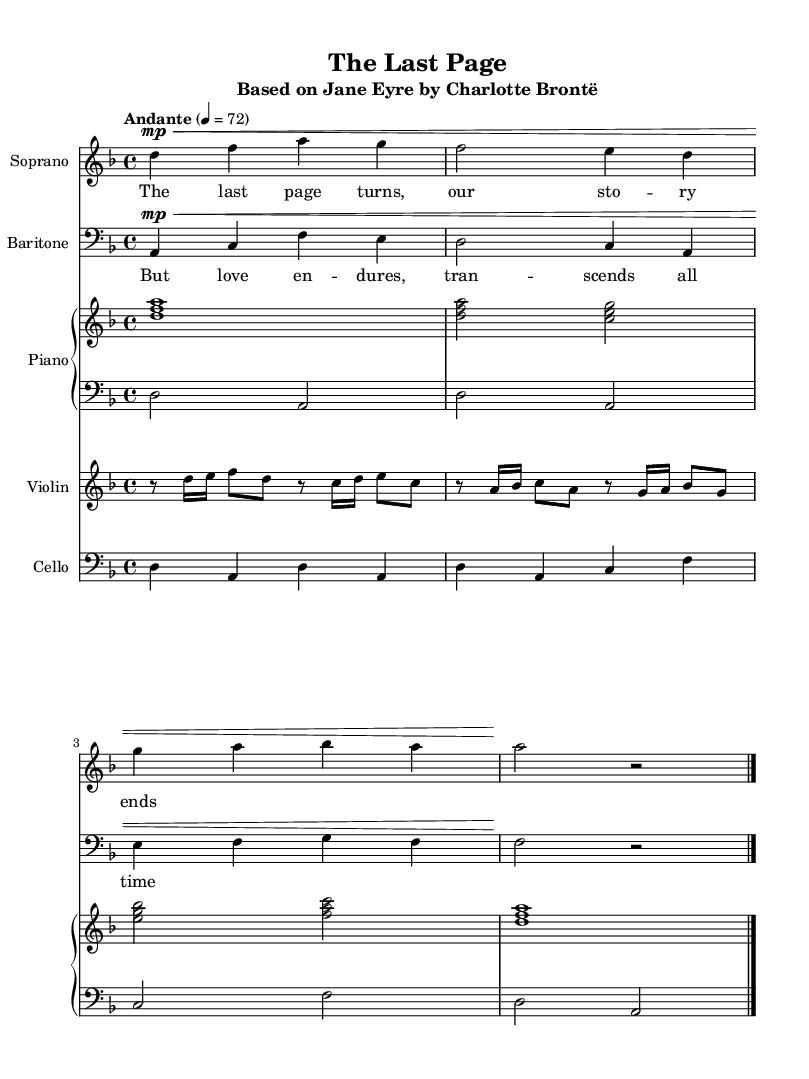What is the key signature of this music? The key signature is indicated at the beginning of the staff; here, it shows two flats, meaning the piece is in D minor.
Answer: D minor What is the time signature of this music? The time signature is displayed at the beginning of the score as a fraction; it shows 4/4, meaning there are four beats in a measure.
Answer: 4/4 What is the tempo marking for this piece? The tempo marking appears at the start; it shows "Andante" with a metronome marking of 4 = 72, indicating a moderate speed.
Answer: Andante How many voices are present in this score? By examining the score, there are two distinct vocal parts labeled as "Soprano" and "Baritone," thus indicating the presence of two voices.
Answer: Two What instrument accompanies the vocal parts? The score includes a "Piano" staff, which is composed of a right-hand and left-hand part, functioning as accompaniment to the vocals.
Answer: Piano What is the lyrical theme of the Soprano part? The lyrics for the Soprano part express a concluding sentiment about the story, as reflected in the line "The last page turns, our story ends."
Answer: The last page turns, our story ends What is a primary motif in the Baritone lyrics? The Baritone lyrics explore the enduring nature of love, expressed through the line "But love endures, transcends all time."
Answer: But love endures, transcends all time 